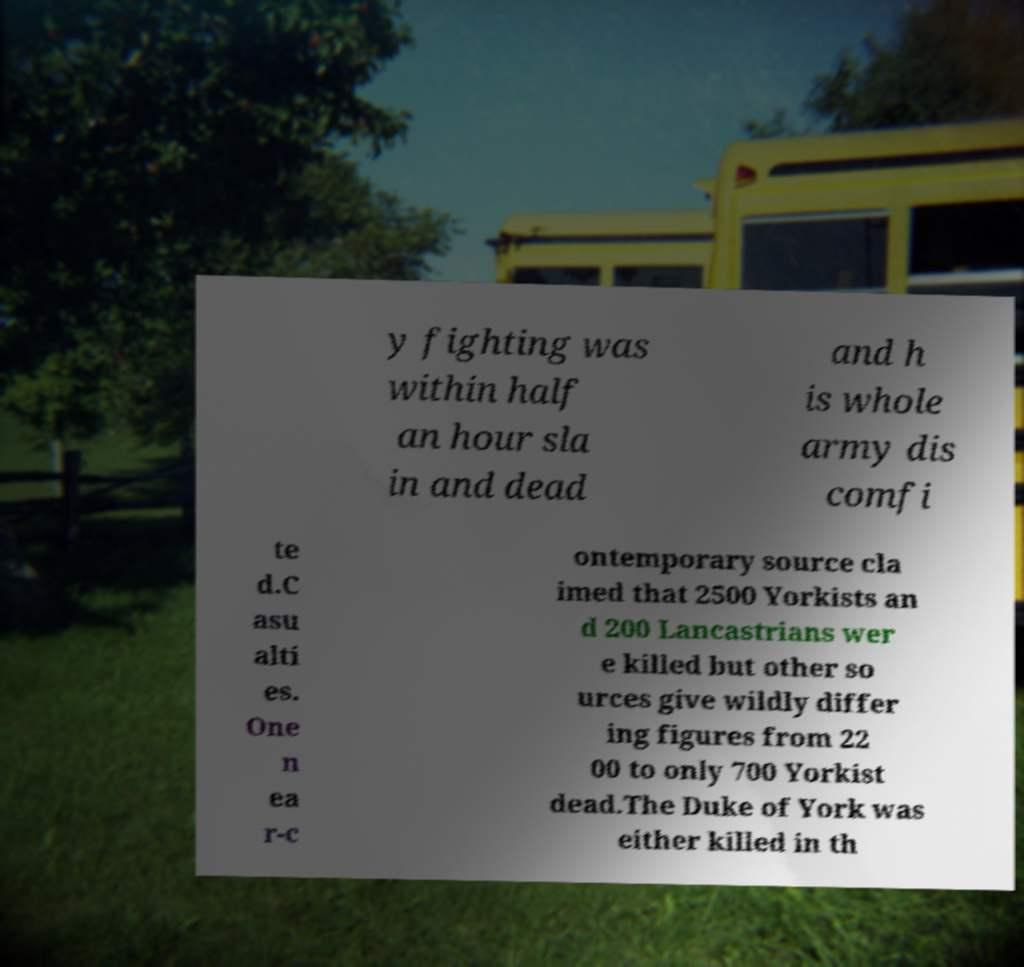Can you accurately transcribe the text from the provided image for me? y fighting was within half an hour sla in and dead and h is whole army dis comfi te d.C asu alti es. One n ea r-c ontemporary source cla imed that 2500 Yorkists an d 200 Lancastrians wer e killed but other so urces give wildly differ ing figures from 22 00 to only 700 Yorkist dead.The Duke of York was either killed in th 